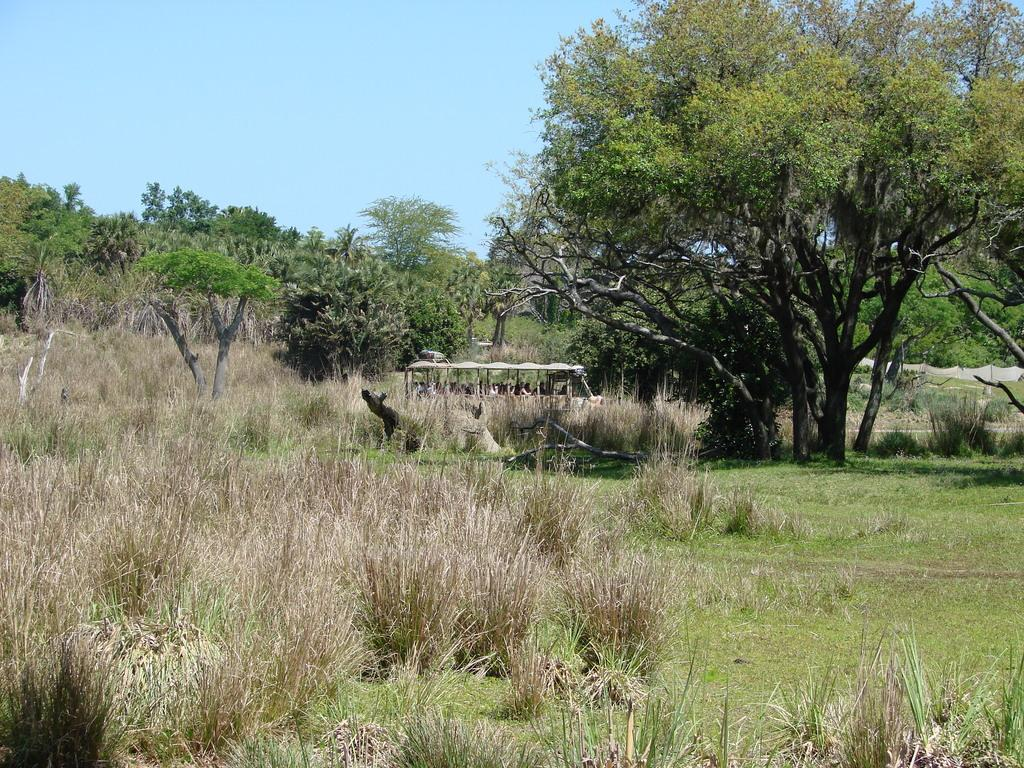What type of vegetation can be seen in the image? There are trees in the image. What else is present in the image besides trees? There is a vehicle and grass visible in the image. What can be seen in the background of the image? The sky is visible in the background of the image. How many grapes are hanging from the trees in the image? There are no grapes present in the image; it features trees without any fruit. What type of coat is draped over the vehicle in the image? There is no coat present in the image; it only features a vehicle and trees. 